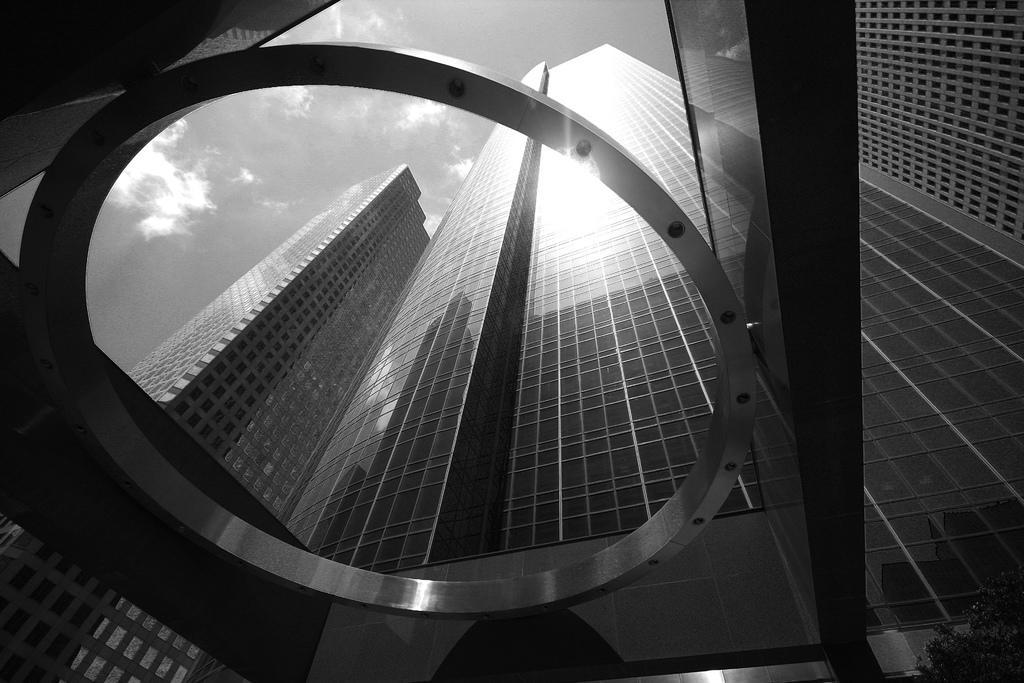In one or two sentences, can you explain what this image depicts? In front of the image there are buildings. At the top of the image there are clouds in the sky. On the right side of the image there is a plant. 